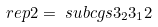<formula> <loc_0><loc_0><loc_500><loc_500>\ r e p { 2 } & = \ s u b c g s { 3 _ { 2 } } { 3 _ { 1 } } { 2 }</formula> 